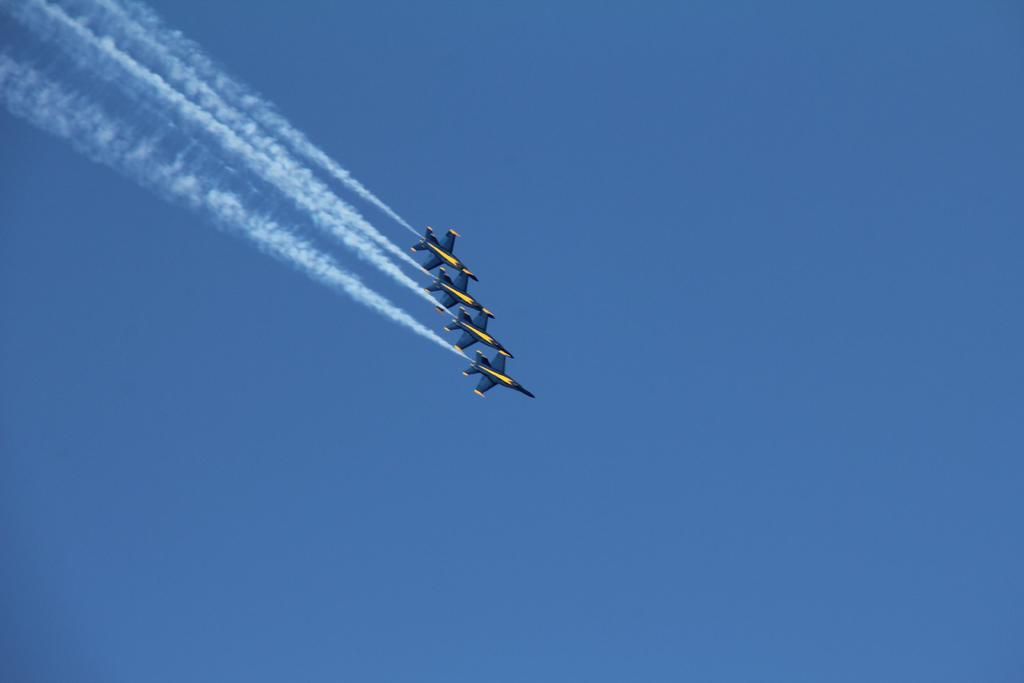Can you describe this image briefly? In the center of the image we can see aeroplanes flying in the sky. 